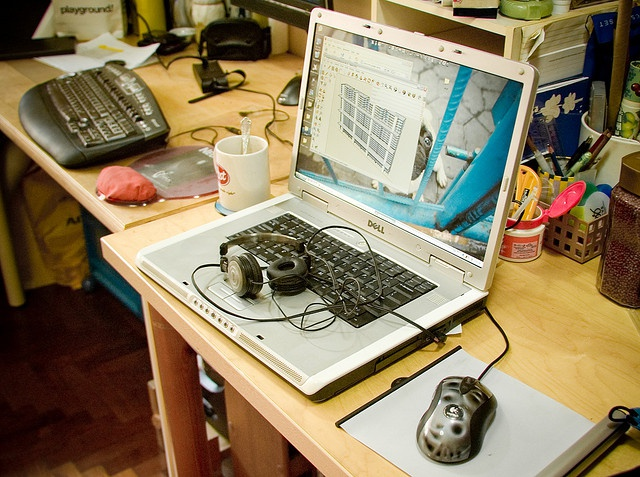Describe the objects in this image and their specific colors. I can see laptop in black, beige, and darkgray tones, keyboard in black, olive, gray, and darkgray tones, keyboard in black, darkgreen, gray, and darkgray tones, mouse in black, gray, darkgray, and darkgreen tones, and cup in black, tan, and ivory tones in this image. 